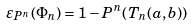Convert formula to latex. <formula><loc_0><loc_0><loc_500><loc_500>\varepsilon _ { P ^ { n } } ( \Phi _ { n } ) = 1 - P ^ { n } ( T _ { n } ( a , b ) )</formula> 